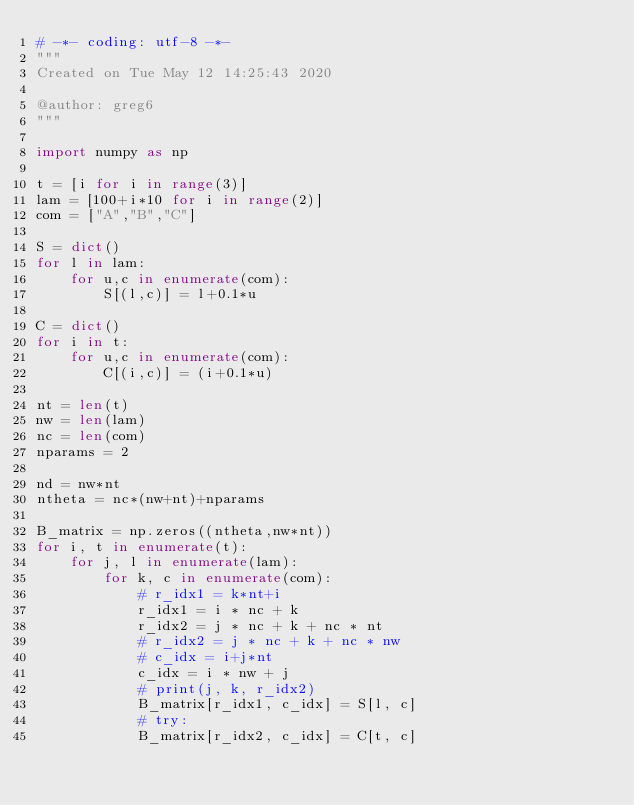Convert code to text. <code><loc_0><loc_0><loc_500><loc_500><_Python_># -*- coding: utf-8 -*-
"""
Created on Tue May 12 14:25:43 2020

@author: greg6
"""

import numpy as np

t = [i for i in range(3)]
lam = [100+i*10 for i in range(2)]
com = ["A","B","C"]

S = dict()
for l in lam:
    for u,c in enumerate(com):
        S[(l,c)] = l+0.1*u

C = dict()
for i in t:
    for u,c in enumerate(com):
        C[(i,c)] = (i+0.1*u)

nt = len(t)
nw = len(lam)
nc = len(com)
nparams = 2

nd = nw*nt
ntheta = nc*(nw+nt)+nparams

B_matrix = np.zeros((ntheta,nw*nt))
for i, t in enumerate(t):
    for j, l in enumerate(lam):
        for k, c in enumerate(com):
            # r_idx1 = k*nt+i
            r_idx1 = i * nc + k
            r_idx2 = j * nc + k + nc * nt
            # r_idx2 = j * nc + k + nc * nw
            # c_idx = i+j*nt
            c_idx = i * nw + j
            # print(j, k, r_idx2)
            B_matrix[r_idx1, c_idx] = S[l, c]
            # try:
            B_matrix[r_idx2, c_idx] = C[t, c]</code> 